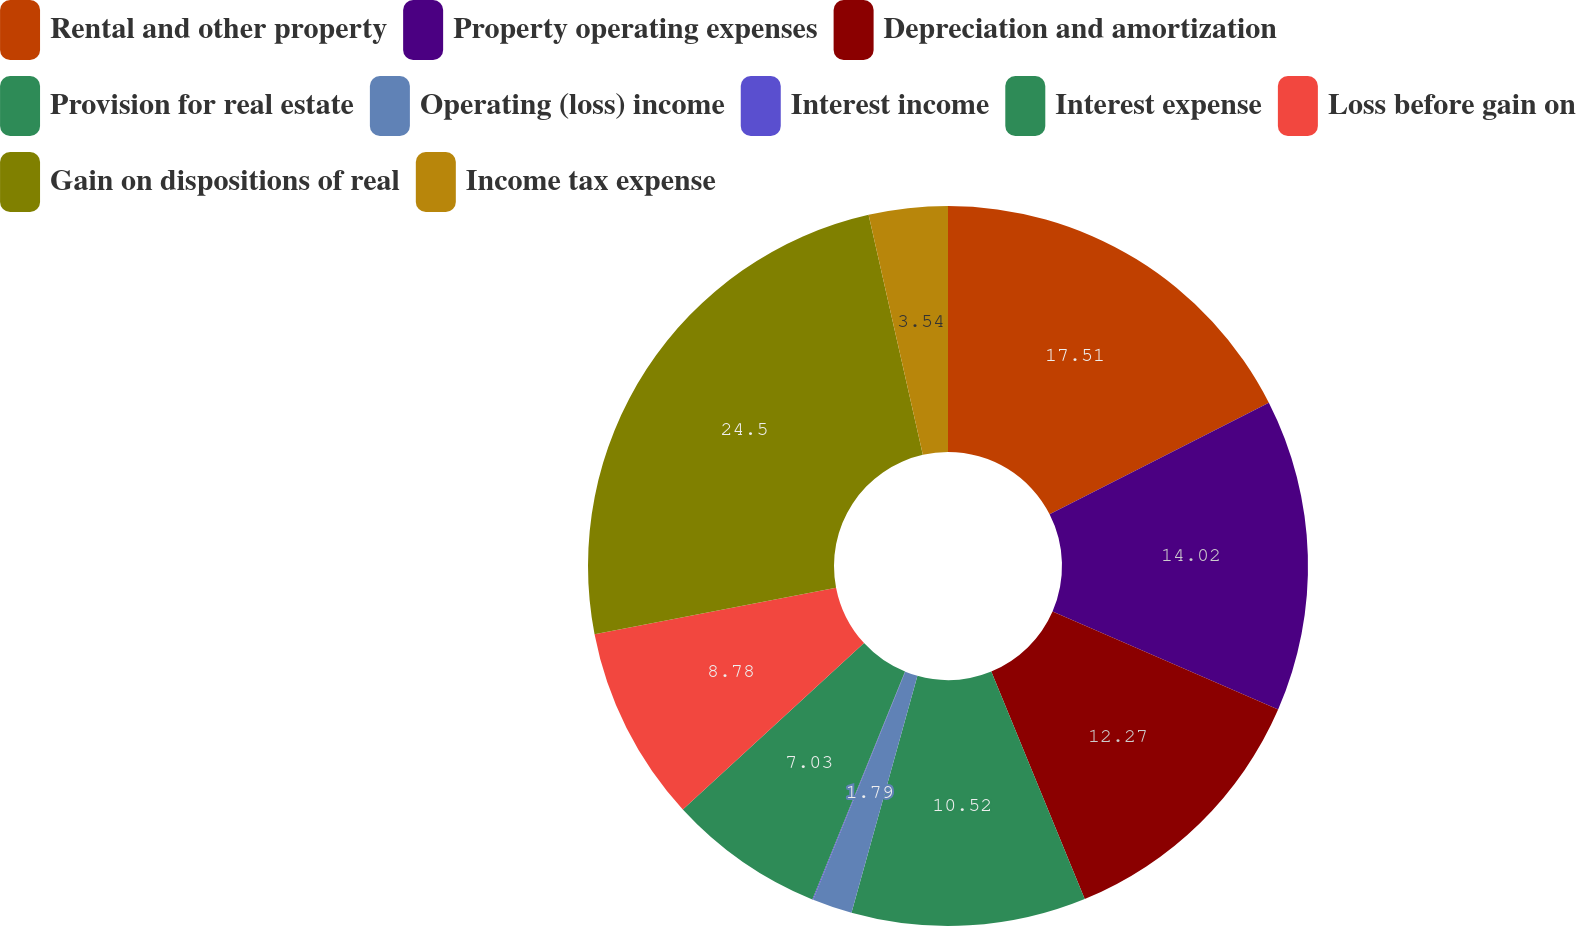Convert chart to OTSL. <chart><loc_0><loc_0><loc_500><loc_500><pie_chart><fcel>Rental and other property<fcel>Property operating expenses<fcel>Depreciation and amortization<fcel>Provision for real estate<fcel>Operating (loss) income<fcel>Interest income<fcel>Interest expense<fcel>Loss before gain on<fcel>Gain on dispositions of real<fcel>Income tax expense<nl><fcel>17.51%<fcel>14.02%<fcel>12.27%<fcel>10.52%<fcel>1.79%<fcel>0.04%<fcel>7.03%<fcel>8.78%<fcel>24.5%<fcel>3.54%<nl></chart> 